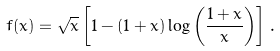<formula> <loc_0><loc_0><loc_500><loc_500>f ( x ) = \sqrt { x } \left [ 1 - ( 1 + x ) \log \left ( \frac { 1 + x } { x } \right ) \right ] \, .</formula> 